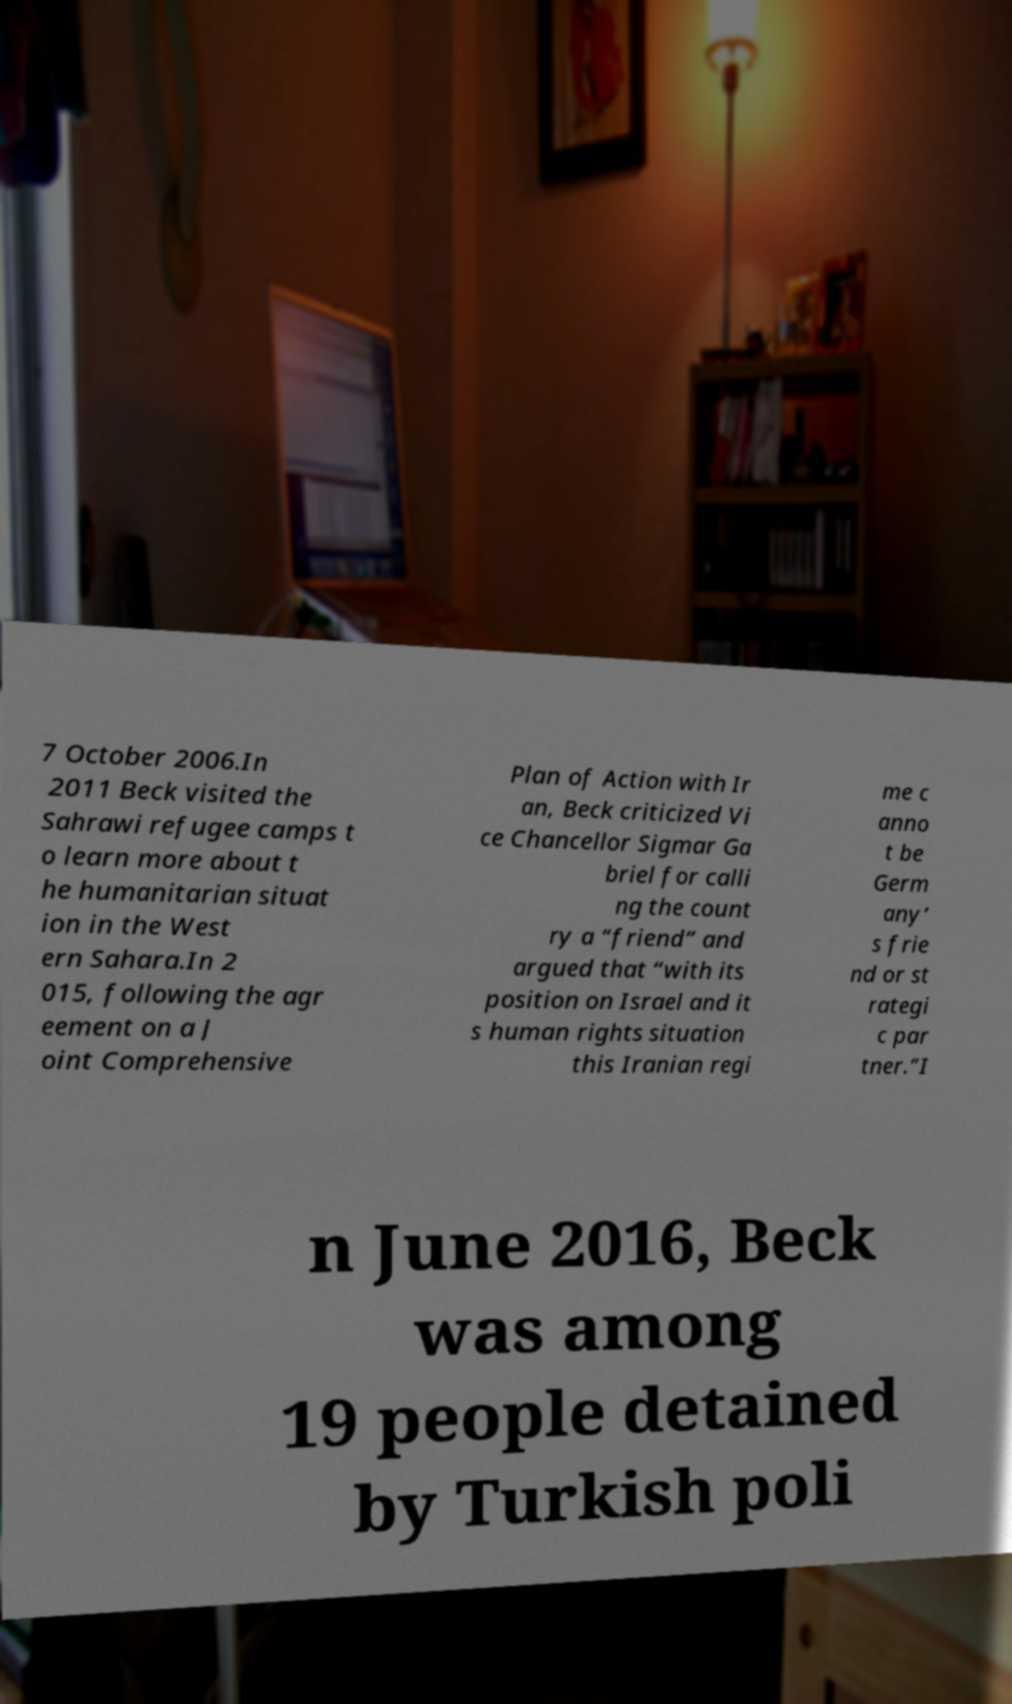Can you read and provide the text displayed in the image?This photo seems to have some interesting text. Can you extract and type it out for me? 7 October 2006.In 2011 Beck visited the Sahrawi refugee camps t o learn more about t he humanitarian situat ion in the West ern Sahara.In 2 015, following the agr eement on a J oint Comprehensive Plan of Action with Ir an, Beck criticized Vi ce Chancellor Sigmar Ga briel for calli ng the count ry a “friend” and argued that “with its position on Israel and it s human rights situation this Iranian regi me c anno t be Germ any’ s frie nd or st rategi c par tner.”I n June 2016, Beck was among 19 people detained by Turkish poli 